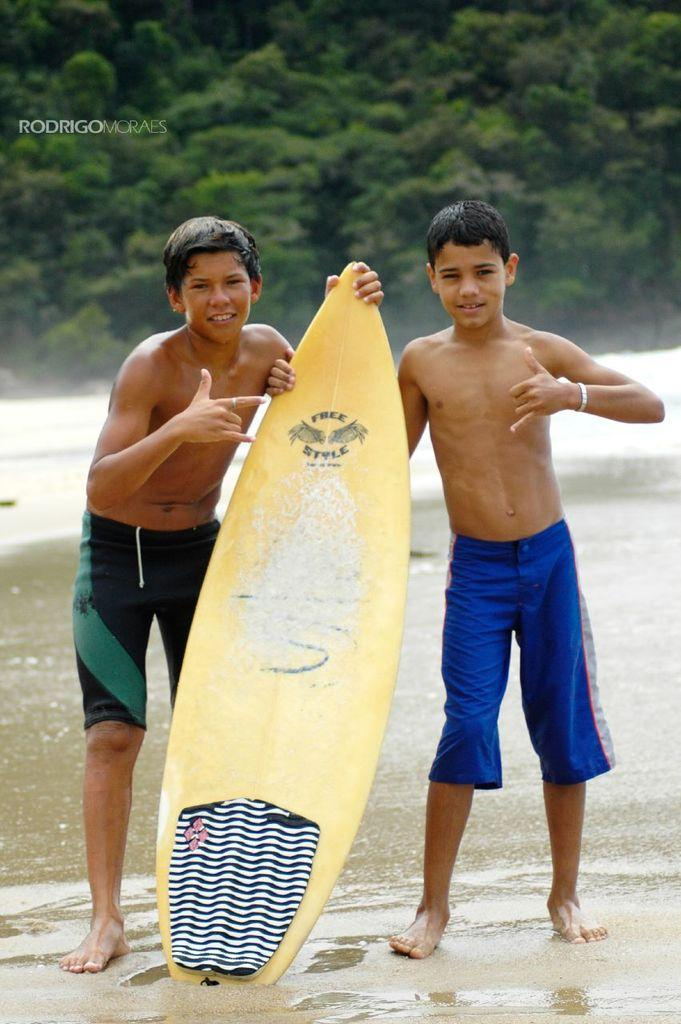How many people are in the picture? There are two boys in the picture. What are the boys doing in the image? The boys are standing and holding a surfboard. What color is the surfboard? The surfboard is yellow in color. What can be seen in the background of the image? Some trees are visible in the background of the image. What type of animal is comforting the boys in the image? There is no animal present in the image, and the boys are not shown receiving comfort from any source. 